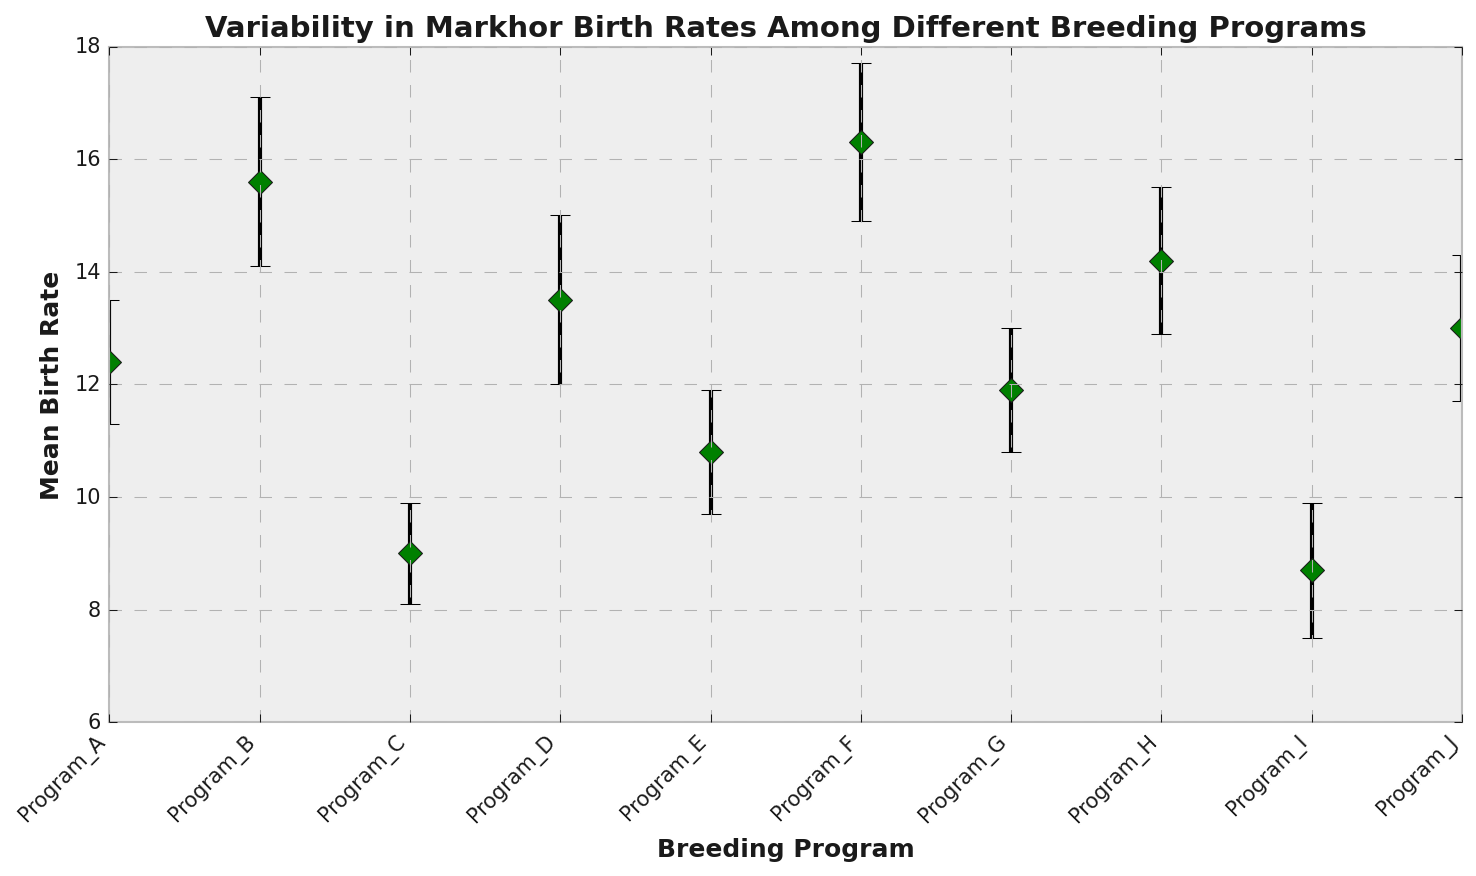What is the breeding program with the highest mean birth rate? Identify the program by looking at the program with the highest mean birth rate on the y-axis. Program F has the highest point.
Answer: Program F Which breeding program has the widest confidence interval? Calculate the range for the confidence intervals for each program. Compare them to identify the widest gap. Program D has the widest confidence interval (15.0 - 12.0 = 3).
Answer: Program D Which breeding programs fall below a mean birth rate of 10? Look for programs with mean birth rates less than 10 on the y-axis. Program C and Program I are below this threshold.
Answer: Program C, Program I What is the difference in mean birth rates between Program B and Program C? Calculate the difference by subtracting the mean birth rate of Program C from that of Program B. 15.6 - 9.0 = 6.6.
Answer: 6.6 Which program has a higher mean birth rate, Program G or Program E? Compare the mean birth rates for Program G and Program E. Program G's mean birth rate (11.9) is higher than Program E's (10.8).
Answer: Program G Are there any programs with overlapping confidence intervals? If so, which ones? Look for confidence intervals that overlap when considering both upper and lower bounds. Programs D and J, among others, overlap within their intervals.
Answer: Yes, Programs D and J What is the mean birth rate range for the entire dataset of breeding programs? Identify the minimum and maximum mean birth rates from the figure. The range is from 8.7 (Program I) to 16.3 (Program F).
Answer: 8.7 to 16.3 What is the average mean birth rate across all programs? Sum all the program mean birth rates and divide by the number of programs (sum = 125.4, number = 10). Average = 125.4 / 10 = 12.54.
Answer: 12.54 Which breeding program has the smallest error bar? Identify the program with the smallest gap between the lower and upper confidence intervals. Program C has the smallest error bar (9.9 - 8.1 = 1.8).
Answer: Program C Is the mean birth rate of Program A within the confidence interval of Program B? Check if 12.4 (Program A's mean birth rate) falls between the lower (14.1) and upper (17.1) confidence intervals of Program B. It does not.
Answer: No 